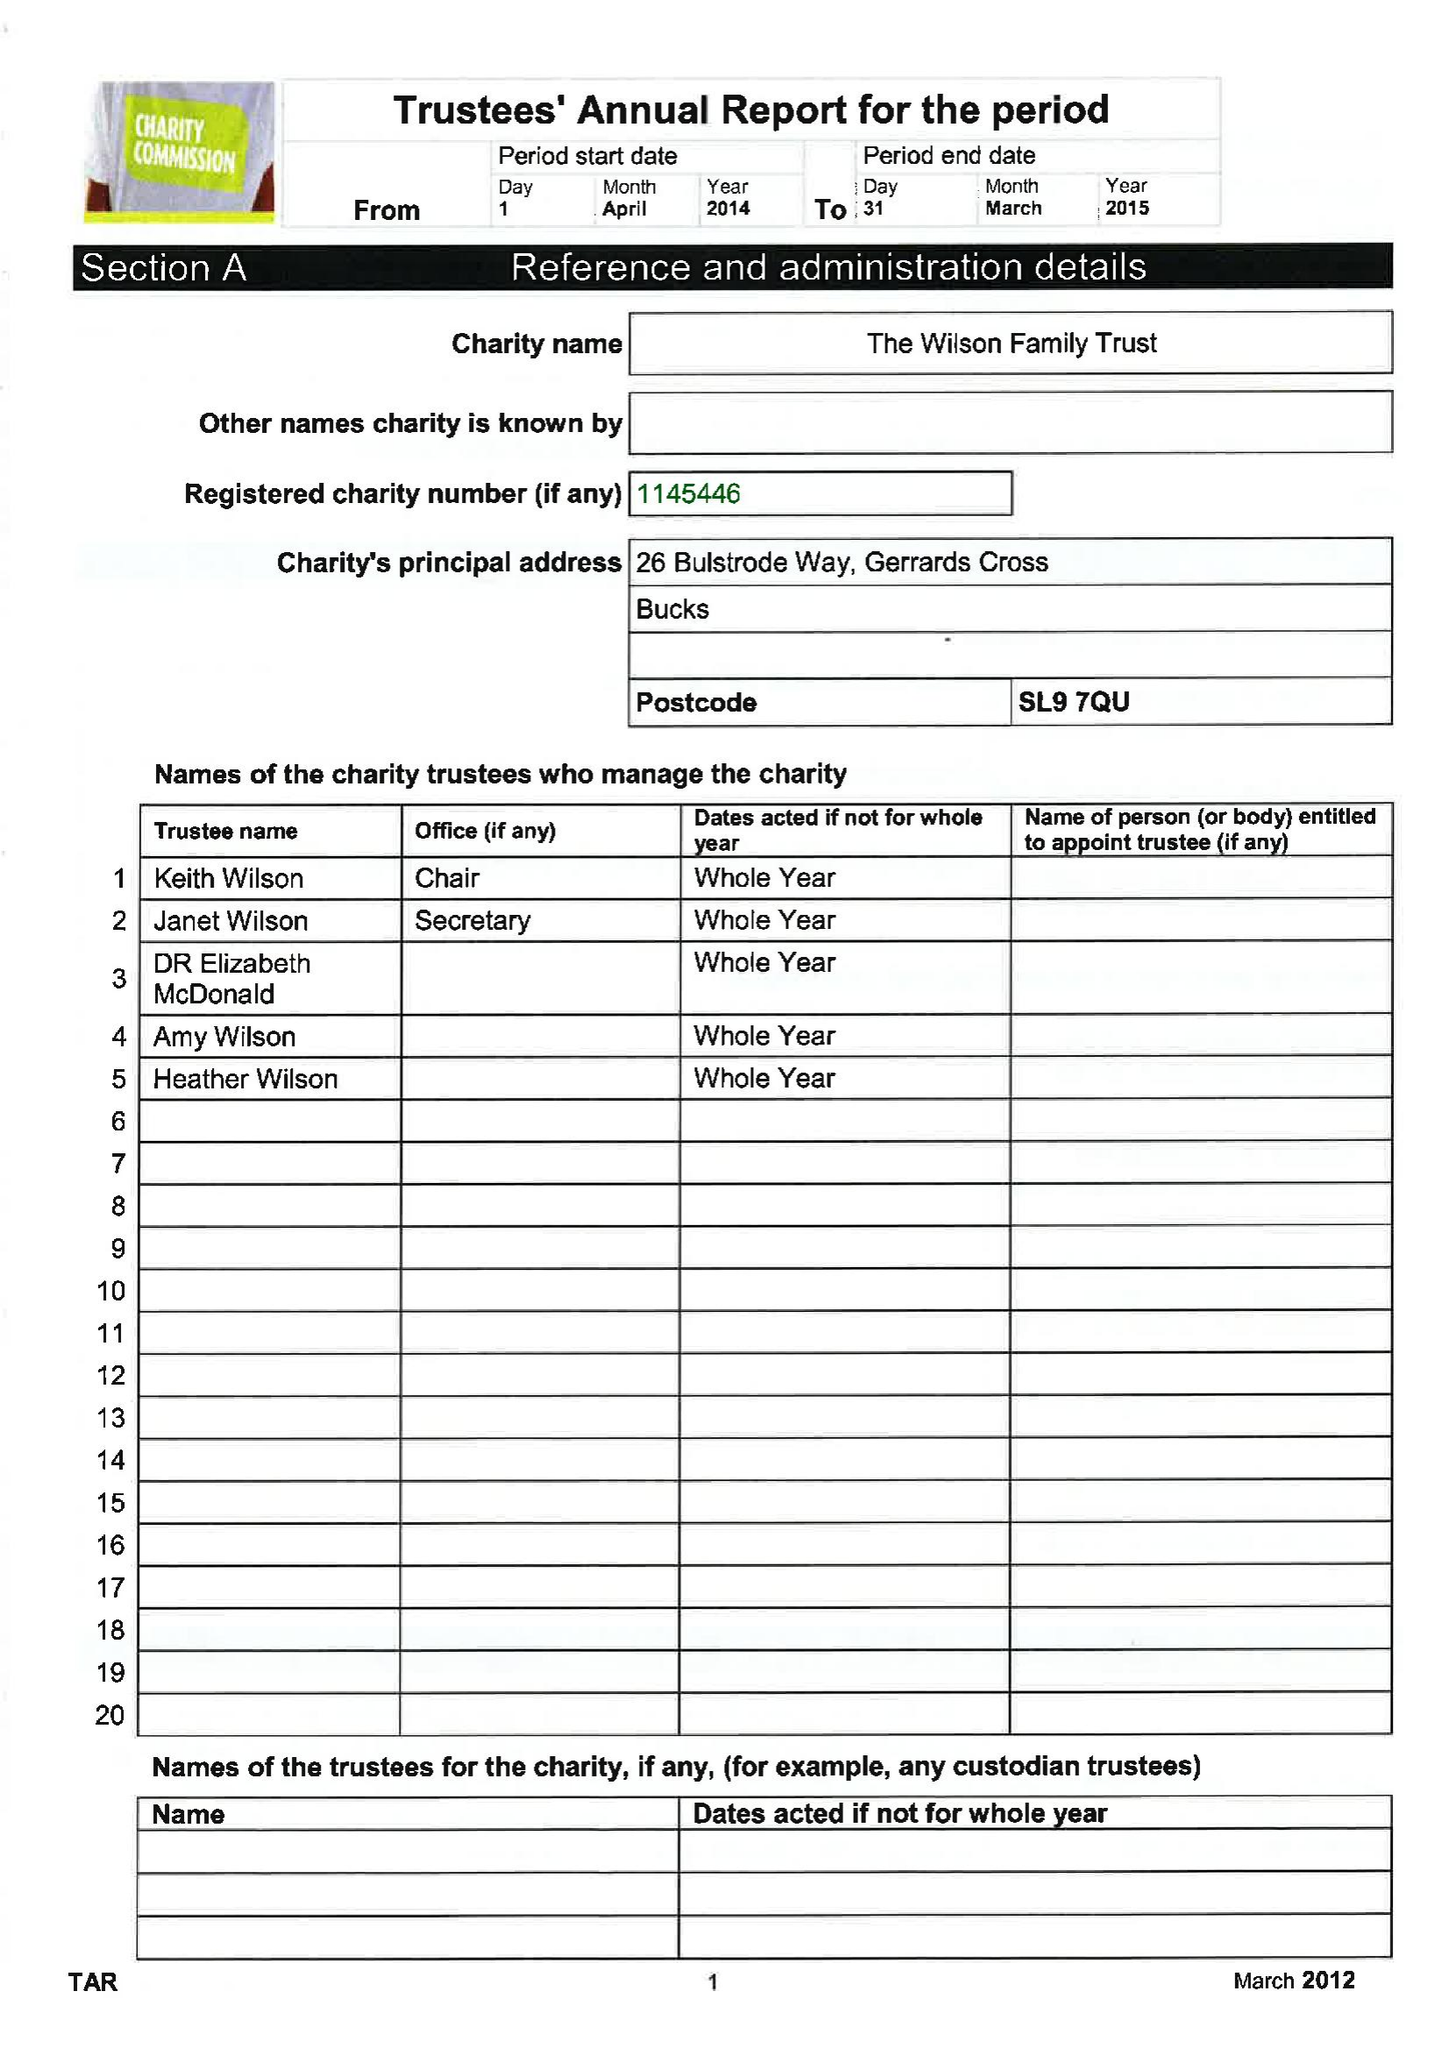What is the value for the spending_annually_in_british_pounds?
Answer the question using a single word or phrase. 78400.00 